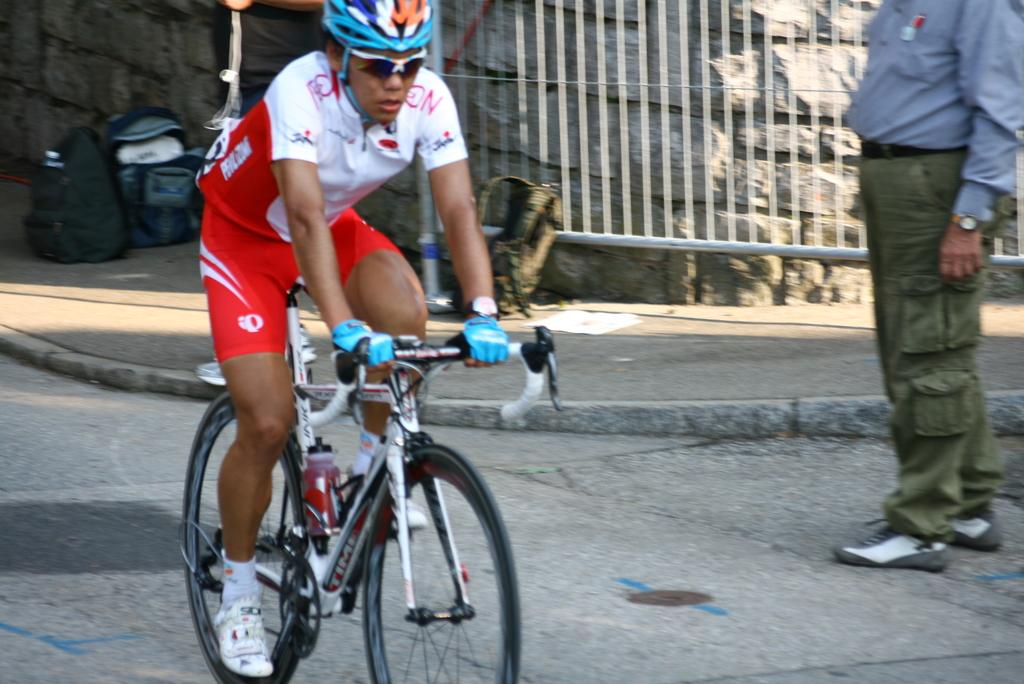What is the main subject of the image? There is a person riding a bicycle in the image. What can be seen on the right side of the image? There is an iron grill on the right side of the image. What type of structure is present in the image? There is a stone wall in the image. What type of health advice can be seen on the stone wall in the image? There is no health advice visible on the stone wall in the image. Can you tell me how many chess pieces are on the bicycle in the image? There are no chess pieces present on the bicycle in the image. 